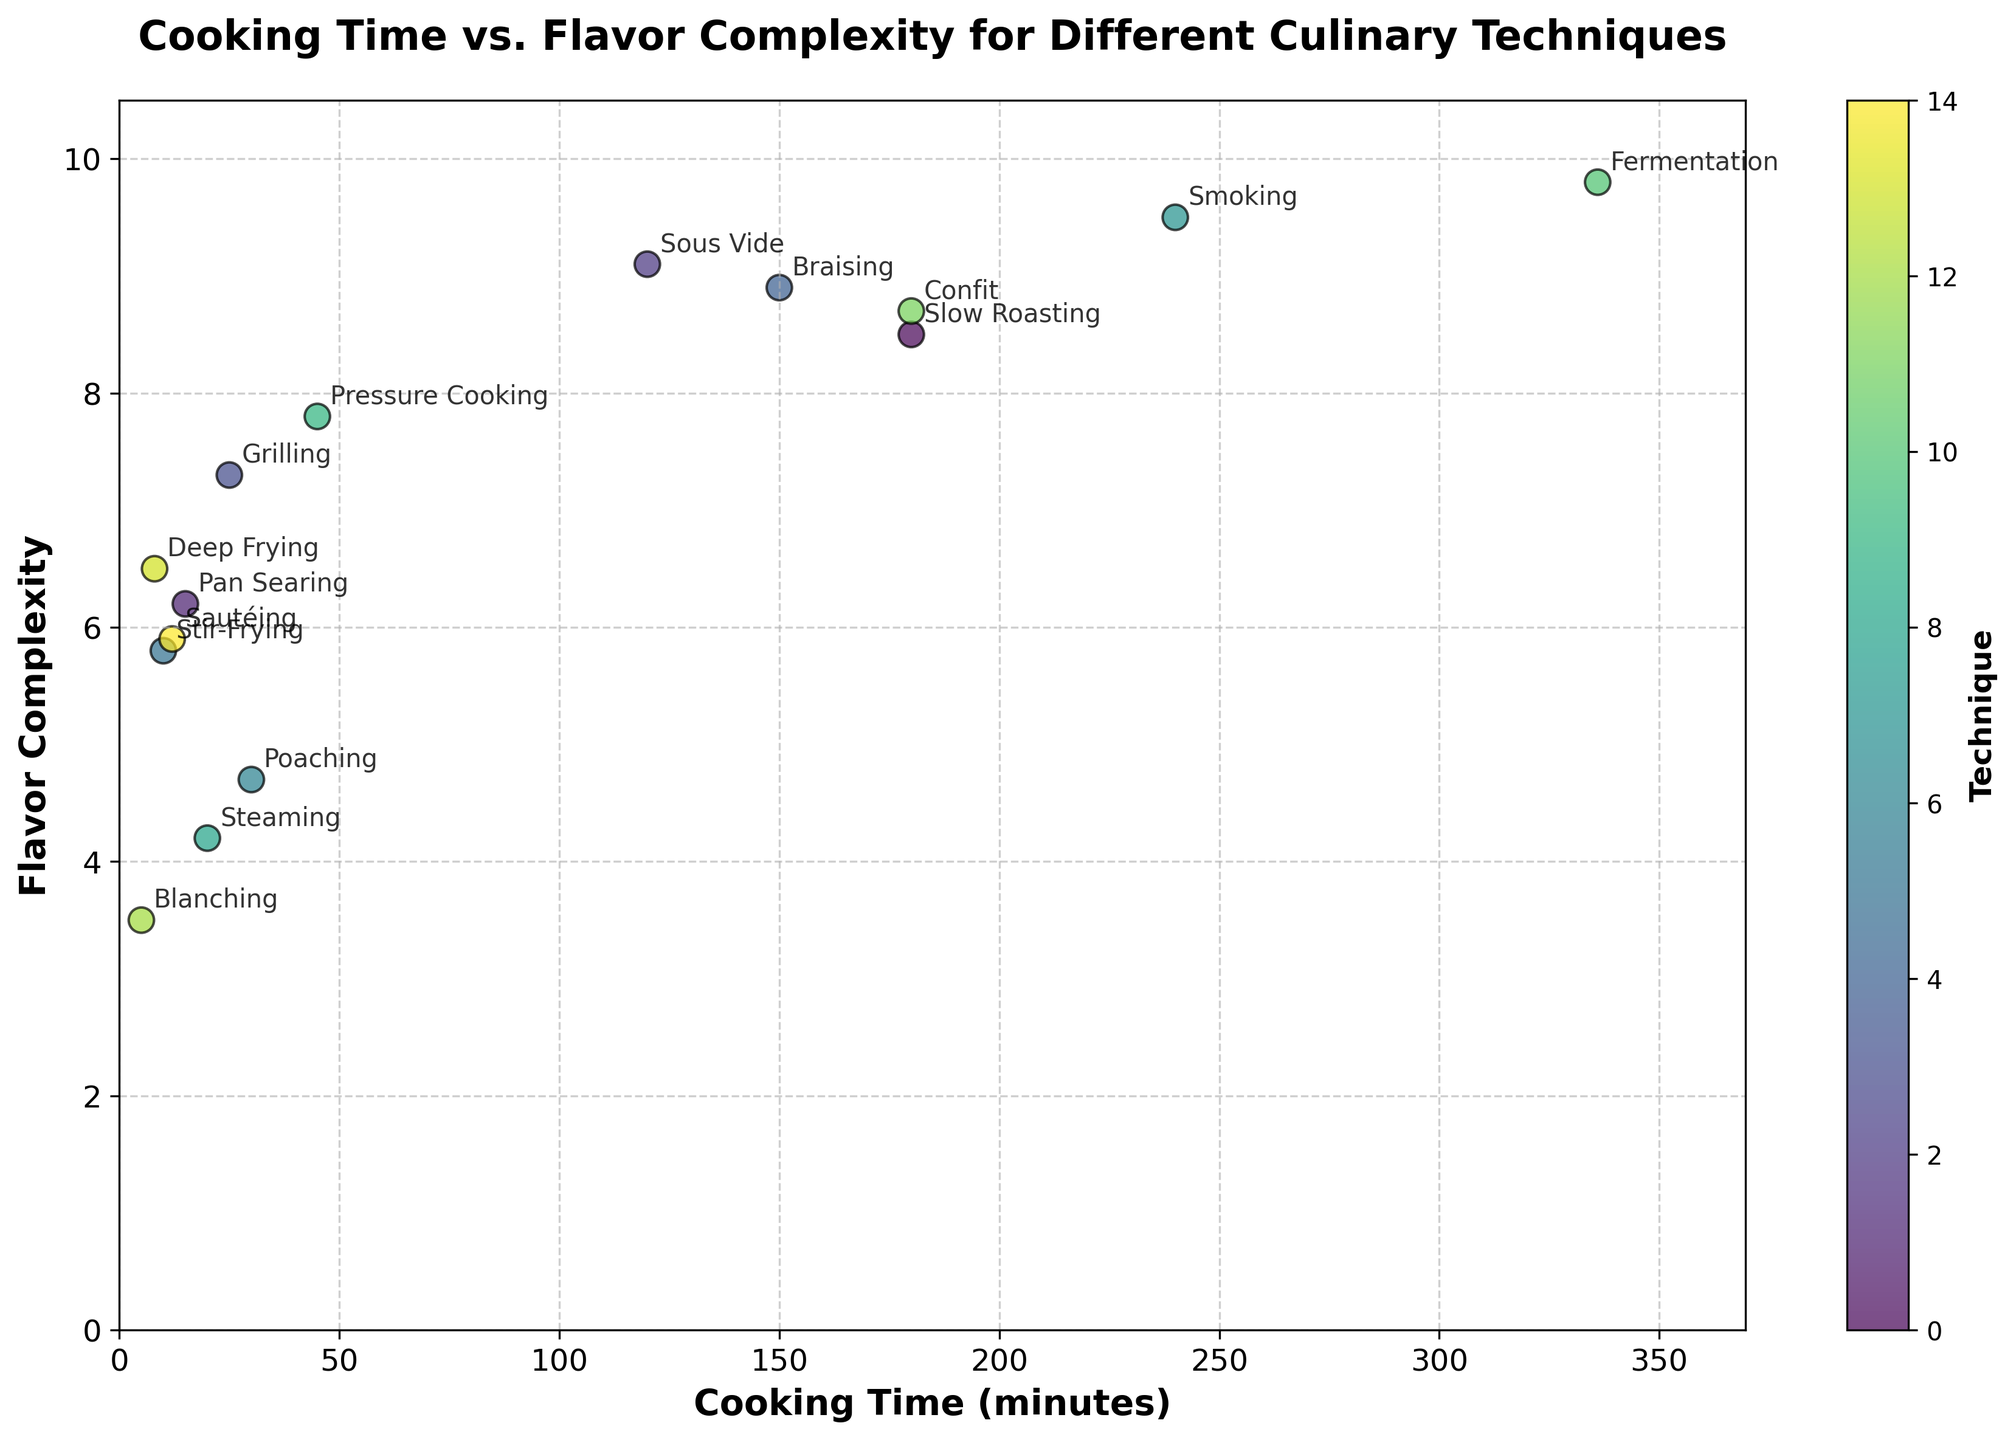What's the title of the figure? The title is usually placed at the top of the figure. In this figure, it's displayed in bold for emphasis.
Answer: Cooking Time vs. Flavor Complexity for Different Culinary Techniques What is the range of cooking times shown in this figure? To find the range, identify the minimum and maximum values on the x-axis. The minimum is 5 minutes (Blanching) and the maximum is 336 minutes (Fermentation).
Answer: 5 to 336 minutes Which culinary technique has the highest flavor complexity? Find the point on the y-axis with the highest value and look at its corresponding technique label.
Answer: Fermentation How does flavor complexity change with cooking time for Pan Searing? Locate the point corresponding to Pan Searing and observe its position on the y-axis for flavor complexity.
Answer: Flavor complexity is 6.2 for a cooking time of 15 minutes Which cooking technique takes the longest time? Look for the data point with the largest x-axis value (cooking time).
Answer: Fermentation Compare the flavor complexity of Grilling and Pan Searing. Identify the points for Grilling and Pan Searing, then compare their positions on the y-axis.
Answer: Grilling (7.3) has a higher flavor complexity than Pan Searing (6.2) What is the most common cooking time range used for the techniques shown? Examine the spread of the scatter points along the x-axis and identify where the majority fall.
Answer: Most points are clustered between 5 and 45 minutes Calculate the average flavor complexity of all techniques. Sum all the flavor complexity values and divide by the number of techniques (15 data points).
Answer: 7.09 Which techniques have a cooking time less than 20 minutes but a flavor complexity higher than 5? Identify points that meet both conditions by checking their x and y values.
Answer: Pan Searing, Stir-Frying, Deep Frying, Sautéing 